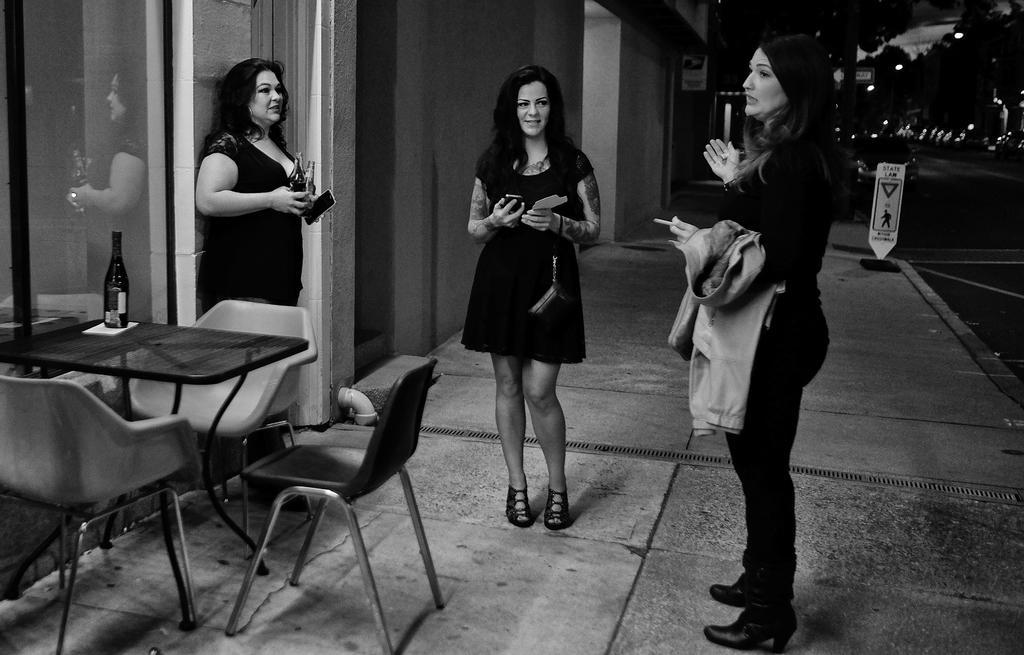Can you describe this image briefly? In this image i can see three women standing and wearing a black outfits, they are holding few objects in their hands, I can see a table and chairs around it. In the background i can see few buildings, a road , a sign board and the sky. 